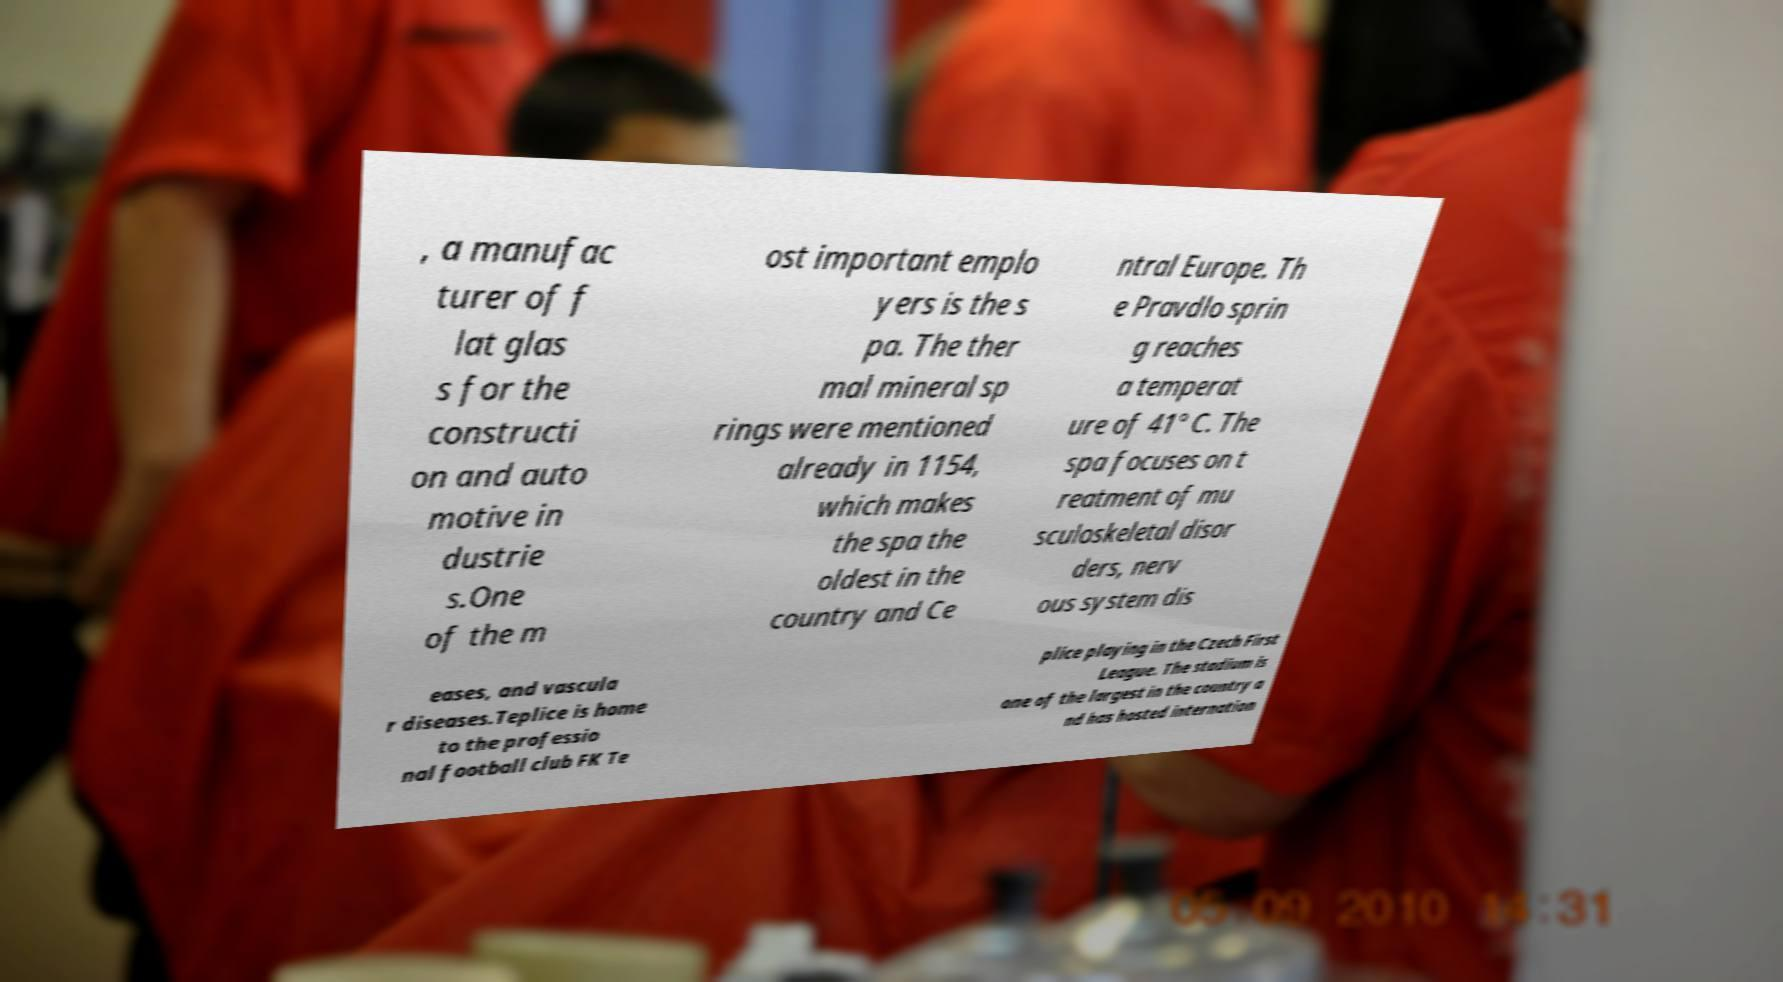Please read and relay the text visible in this image. What does it say? , a manufac turer of f lat glas s for the constructi on and auto motive in dustrie s.One of the m ost important emplo yers is the s pa. The ther mal mineral sp rings were mentioned already in 1154, which makes the spa the oldest in the country and Ce ntral Europe. Th e Pravdlo sprin g reaches a temperat ure of 41° C. The spa focuses on t reatment of mu sculoskeletal disor ders, nerv ous system dis eases, and vascula r diseases.Teplice is home to the professio nal football club FK Te plice playing in the Czech First League. The stadium is one of the largest in the country a nd has hosted internation 